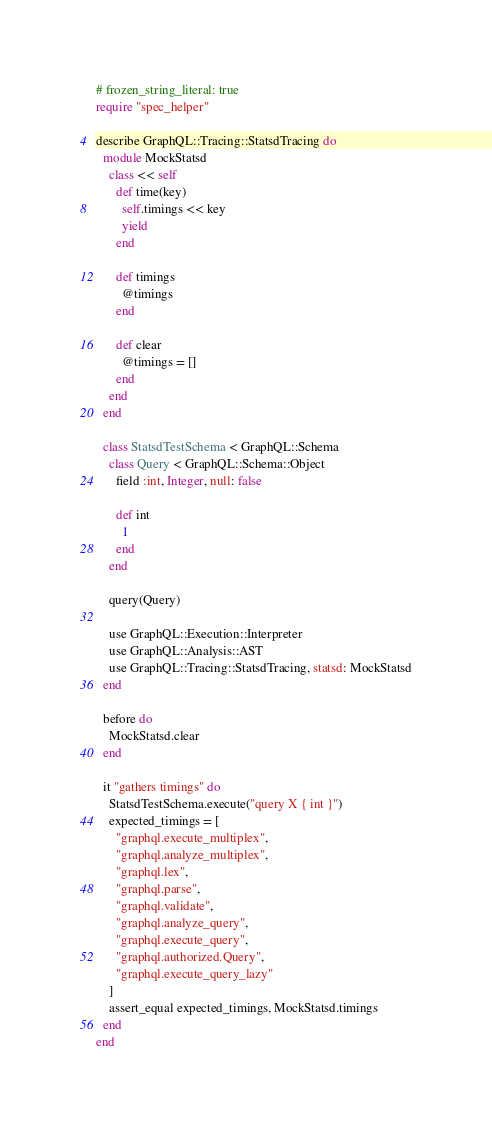<code> <loc_0><loc_0><loc_500><loc_500><_Ruby_># frozen_string_literal: true
require "spec_helper"

describe GraphQL::Tracing::StatsdTracing do
  module MockStatsd
    class << self
      def time(key)
        self.timings << key
        yield
      end

      def timings
        @timings
      end

      def clear
        @timings = []
      end
    end
  end

  class StatsdTestSchema < GraphQL::Schema
    class Query < GraphQL::Schema::Object
      field :int, Integer, null: false

      def int
        1
      end
    end

    query(Query)

    use GraphQL::Execution::Interpreter
    use GraphQL::Analysis::AST
    use GraphQL::Tracing::StatsdTracing, statsd: MockStatsd
  end

  before do
    MockStatsd.clear
  end

  it "gathers timings" do
    StatsdTestSchema.execute("query X { int }")
    expected_timings = [
      "graphql.execute_multiplex",
      "graphql.analyze_multiplex",
      "graphql.lex",
      "graphql.parse",
      "graphql.validate",
      "graphql.analyze_query",
      "graphql.execute_query",
      "graphql.authorized.Query",
      "graphql.execute_query_lazy"
    ]
    assert_equal expected_timings, MockStatsd.timings
  end
end
</code> 